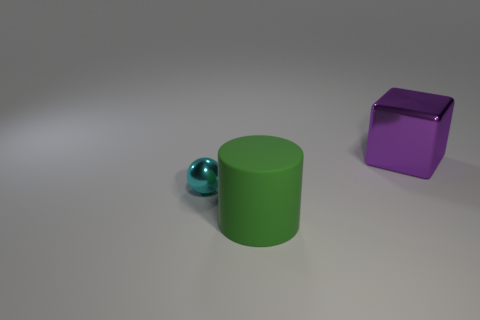Could you guess the size of these objects relative to each other? The sizes of the objects relative to each other suggest the green cylinder is the largest. It is followed by the purple cube, which appears smaller in size. The blue sphere is the smallest object present. Without any context or known objects for scale, these are approximate guesses based on their appearance in the image. 